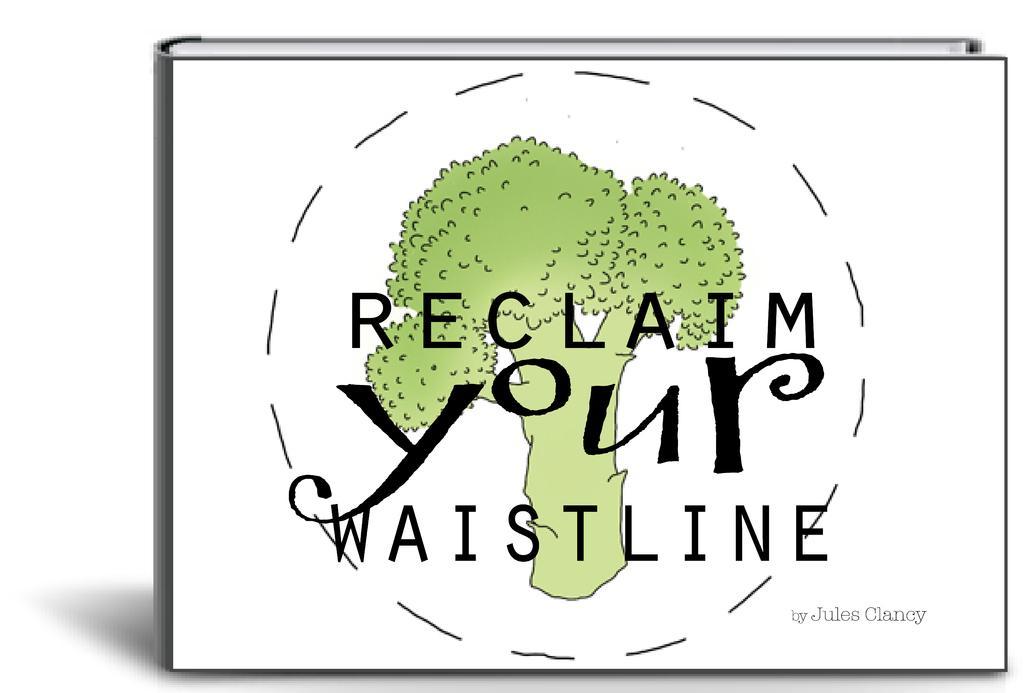Please provide a concise description of this image. This is a graphic image. In this there is a book on it is a painting of a tree. Few texts are there on the cover page. 